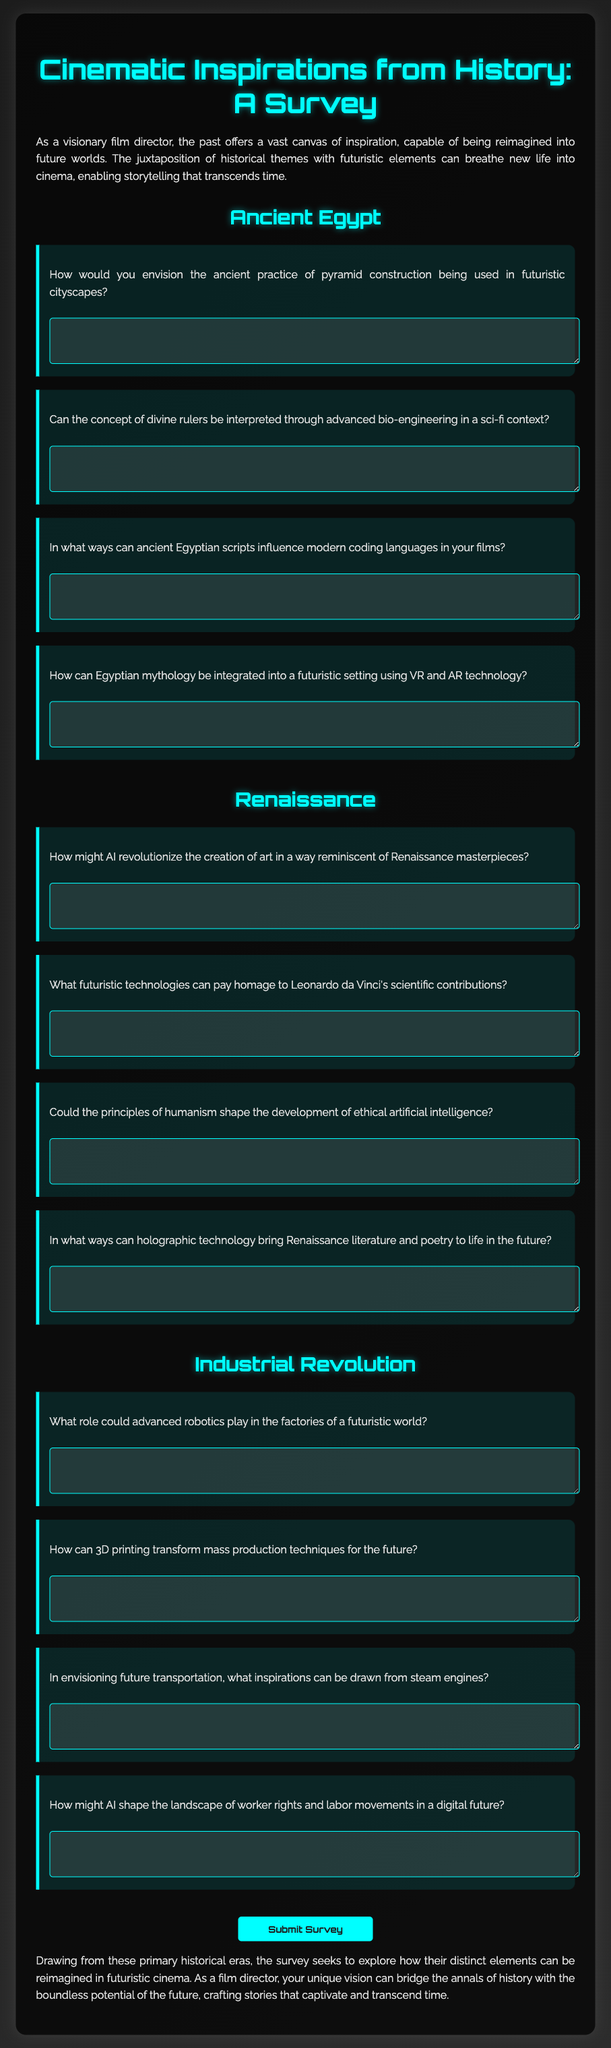What is the title of the survey? The title of the survey is provided at the top of the document.
Answer: Cinematic Inspirations from History: A Survey How many historical eras are explored in the survey? The document lists three distinct historical eras.
Answer: Three What futuristic technology is mentioned in the Renaissance section? The Renaissance section mentions holographic technology.
Answer: Holographic technology What is the primary focus of the survey? The primary focus of the survey is to explore the reimagining of historical elements in futuristic cinema.
Answer: Reimagining historical elements in futuristic cinema Which ancient civilization is referenced in the survey? The survey references ancient Egypt specifically in its questions.
Answer: Ancient Egypt What type of format is used for collecting responses in the document? The document uses a form with text areas for respondents to provide answers.
Answer: Form with text areas Which section includes questions about robotics? The questions about robotics are included in the Industrial Revolution section.
Answer: Industrial Revolution section What color scheme is used for the headings in the document? The headings in the document are colored cyan, as indicated in the styling section.
Answer: Cyan 